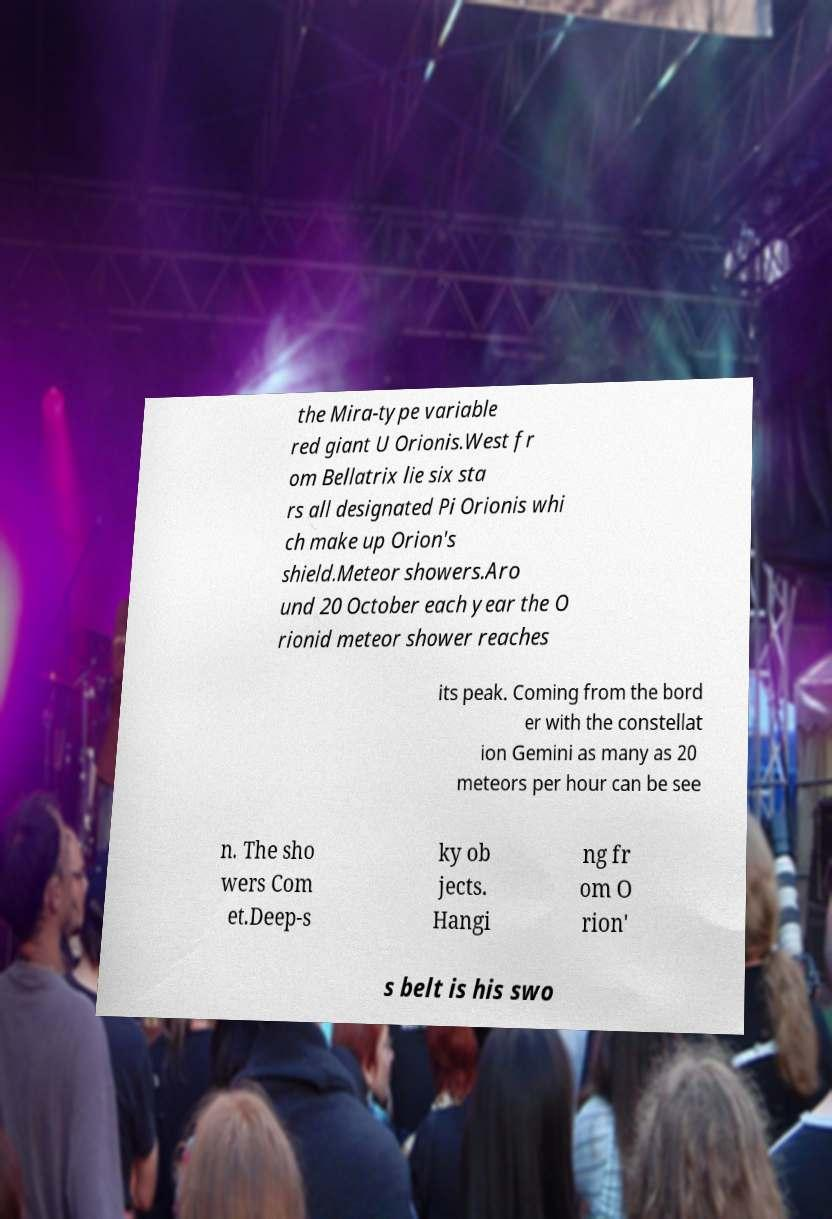Can you accurately transcribe the text from the provided image for me? the Mira-type variable red giant U Orionis.West fr om Bellatrix lie six sta rs all designated Pi Orionis whi ch make up Orion's shield.Meteor showers.Aro und 20 October each year the O rionid meteor shower reaches its peak. Coming from the bord er with the constellat ion Gemini as many as 20 meteors per hour can be see n. The sho wers Com et.Deep-s ky ob jects. Hangi ng fr om O rion' s belt is his swo 